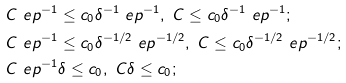<formula> <loc_0><loc_0><loc_500><loc_500>& C \ e p ^ { - 1 } \leq c _ { 0 } \delta ^ { - 1 } \ e p ^ { - 1 } , \ C \leq c _ { 0 } \delta ^ { - 1 } \ e p ^ { - 1 } ; \\ & C \ e p ^ { - 1 } \leq c _ { 0 } \delta ^ { - 1 / 2 } \ e p ^ { - 1 / 2 } , \ C \leq c _ { 0 } \delta ^ { - 1 / 2 } \ e p ^ { - 1 / 2 } ; \\ & C \ e p ^ { - 1 } \delta \leq c _ { 0 } , \ C \delta \leq c _ { 0 } ;</formula> 